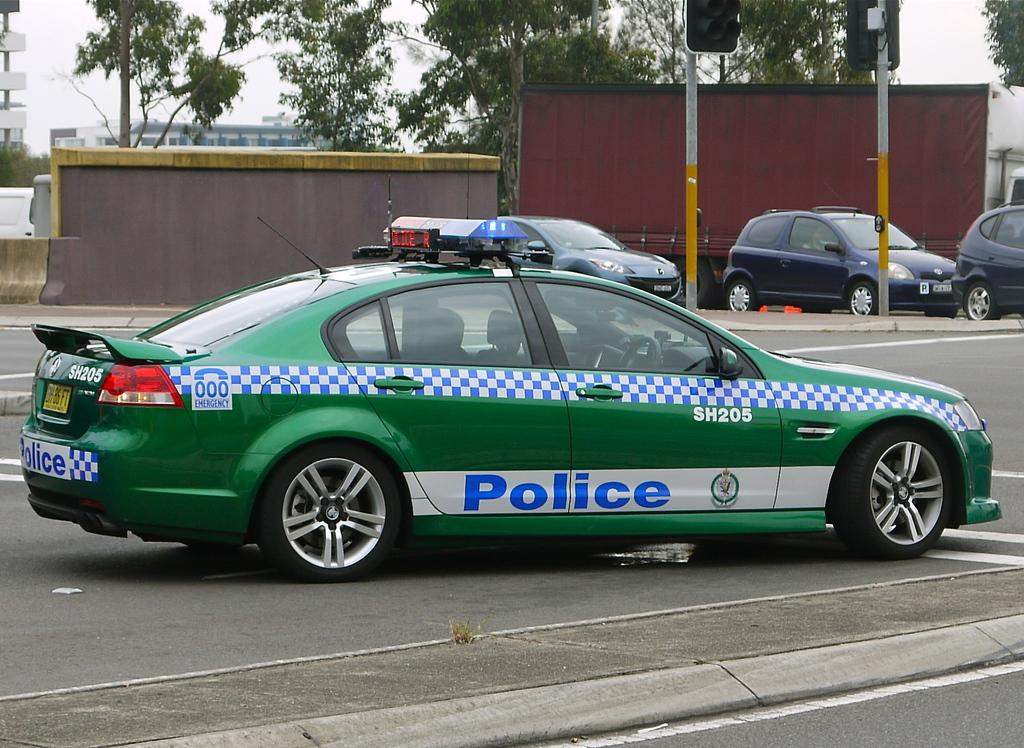<image>
Share a concise interpretation of the image provided. A green and checkered pattern police care is parked in a parking lot. 